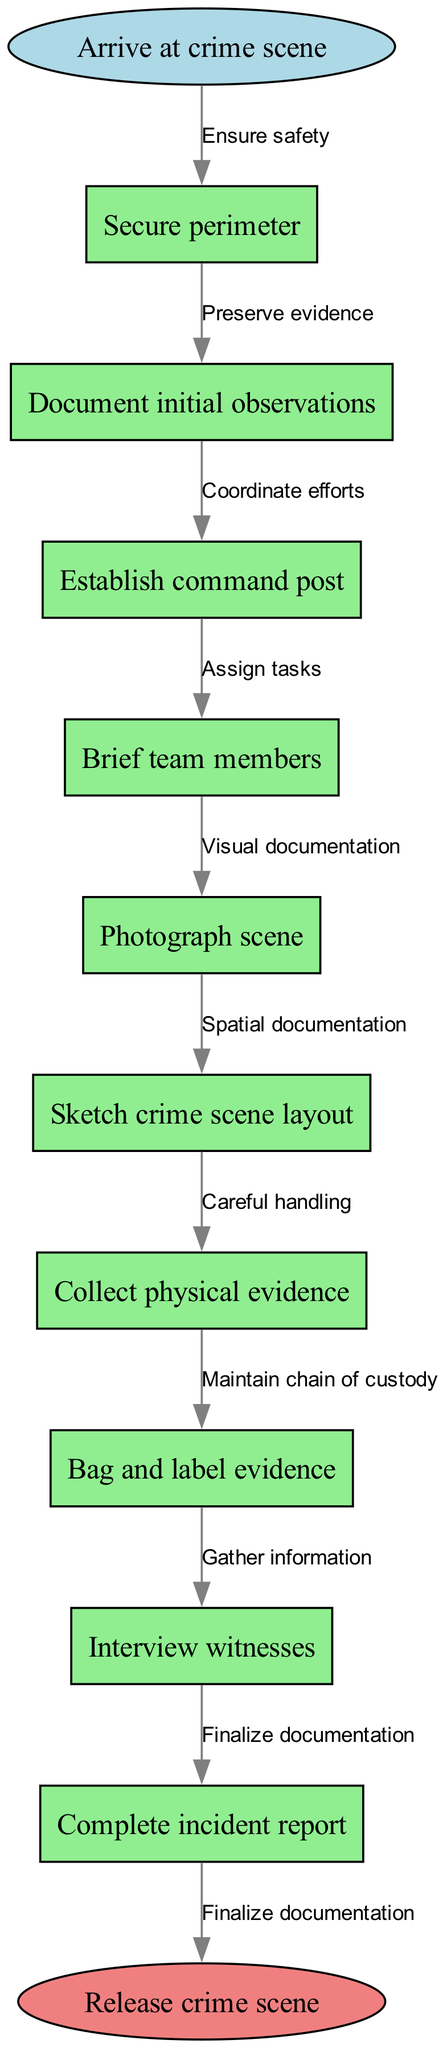What is the starting point of the protocol? The starting point is indicated by the first node, which states "Arrive at crime scene."
Answer: Arrive at crime scene How many nodes are present in the diagram? To find the total number of nodes, we count the nodes listed in the data: there are 10 nodes in total.
Answer: 10 What follows "Secure perimeter" in the protocol? The edge from "Secure perimeter" leads to the next node, which is "Document initial observations."
Answer: Document initial observations What is the last step before releasing the crime scene? The process ends with the node that states "Complete incident report" before moving to the end node labeled "Release crime scene."
Answer: Complete incident report Which node is connected directly to "Establish command post"? By examining the flow, "Establish command post" connects directly to "Brief team members."
Answer: Brief team members How many edges are there in the diagram? The number of edges corresponds to the number of connections between nodes; there are 9 edges in total in this diagram.
Answer: 9 What document is created at the end of the protocol? The last action before releasing the scene involves "Complete incident report," which indicates documentation is created.
Answer: Incident report Which node involves gathering information? "Interview witnesses" is the node where information gathering occurs, as it aims to collect insights from those who saw the crime.
Answer: Interview witnesses What is the significance of the edge labeled "Maintain chain of custody"? This edge emphasizes the need for careful handling and accurate documentation of evidence to ensure it remains legal and usable in court.
Answer: Preserve evidence 